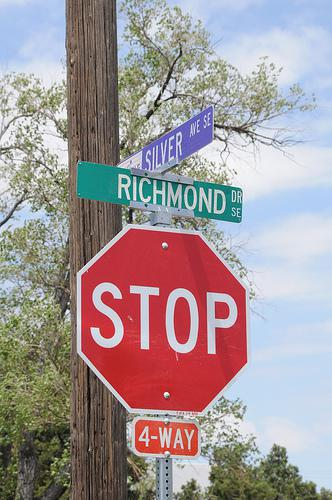Question: what does it say below stop?
Choices:
A. 2 way.
B. 1 way.
C. 4-way.
D. Nothing.
Answer with the letter. Answer: C Question: what color is the Richmond sign?
Choices:
A. Blue.
B. Green.
C. Brown.
D. Red.
Answer with the letter. Answer: B Question: when was the photo taken?
Choices:
A. During the day.
B. At night.
C. At sunrise.
D. At sunset.
Answer with the letter. Answer: A 